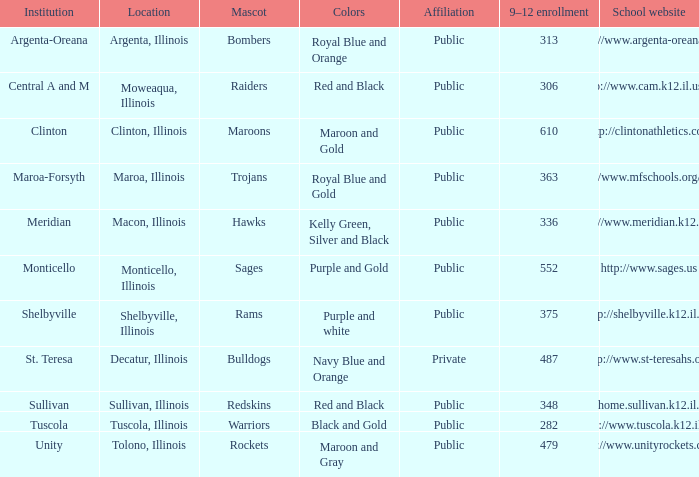What site has 363 students enrolled in grades 9 through 12? Maroa, Illinois. 